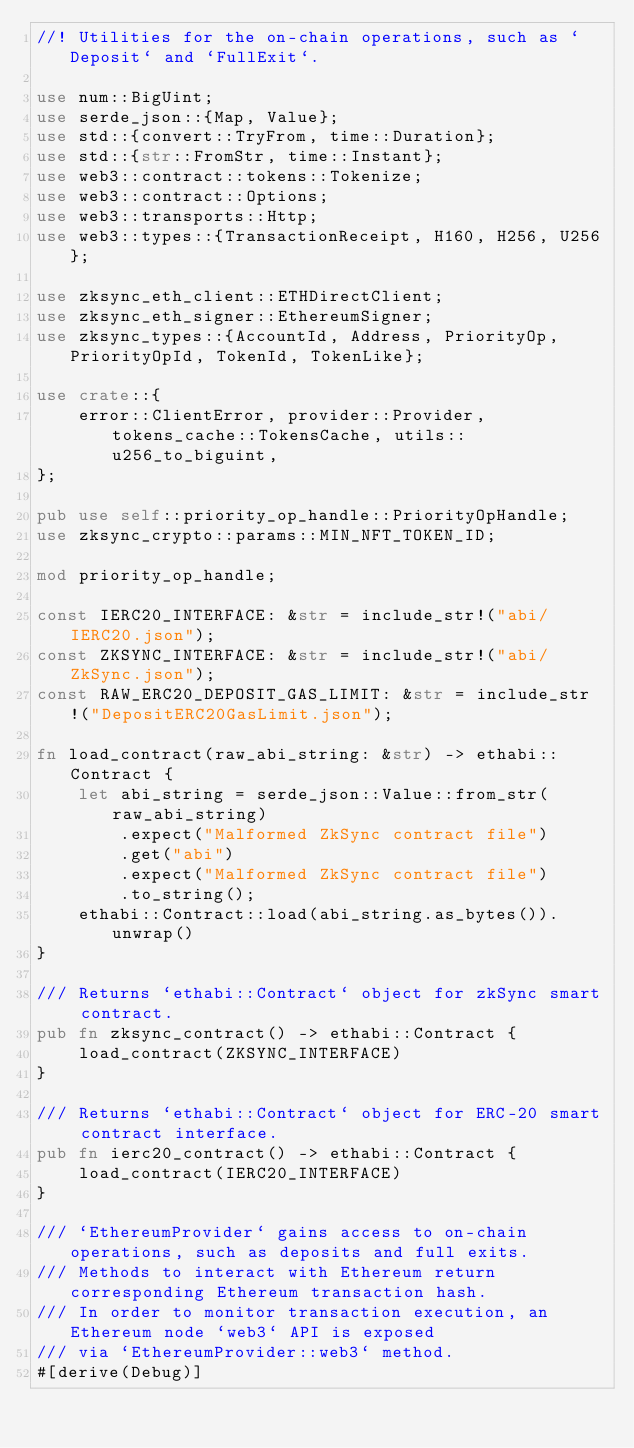Convert code to text. <code><loc_0><loc_0><loc_500><loc_500><_Rust_>//! Utilities for the on-chain operations, such as `Deposit` and `FullExit`.

use num::BigUint;
use serde_json::{Map, Value};
use std::{convert::TryFrom, time::Duration};
use std::{str::FromStr, time::Instant};
use web3::contract::tokens::Tokenize;
use web3::contract::Options;
use web3::transports::Http;
use web3::types::{TransactionReceipt, H160, H256, U256};

use zksync_eth_client::ETHDirectClient;
use zksync_eth_signer::EthereumSigner;
use zksync_types::{AccountId, Address, PriorityOp, PriorityOpId, TokenId, TokenLike};

use crate::{
    error::ClientError, provider::Provider, tokens_cache::TokensCache, utils::u256_to_biguint,
};

pub use self::priority_op_handle::PriorityOpHandle;
use zksync_crypto::params::MIN_NFT_TOKEN_ID;

mod priority_op_handle;

const IERC20_INTERFACE: &str = include_str!("abi/IERC20.json");
const ZKSYNC_INTERFACE: &str = include_str!("abi/ZkSync.json");
const RAW_ERC20_DEPOSIT_GAS_LIMIT: &str = include_str!("DepositERC20GasLimit.json");

fn load_contract(raw_abi_string: &str) -> ethabi::Contract {
    let abi_string = serde_json::Value::from_str(raw_abi_string)
        .expect("Malformed ZkSync contract file")
        .get("abi")
        .expect("Malformed ZkSync contract file")
        .to_string();
    ethabi::Contract::load(abi_string.as_bytes()).unwrap()
}

/// Returns `ethabi::Contract` object for zkSync smart contract.
pub fn zksync_contract() -> ethabi::Contract {
    load_contract(ZKSYNC_INTERFACE)
}

/// Returns `ethabi::Contract` object for ERC-20 smart contract interface.
pub fn ierc20_contract() -> ethabi::Contract {
    load_contract(IERC20_INTERFACE)
}

/// `EthereumProvider` gains access to on-chain operations, such as deposits and full exits.
/// Methods to interact with Ethereum return corresponding Ethereum transaction hash.
/// In order to monitor transaction execution, an Ethereum node `web3` API is exposed
/// via `EthereumProvider::web3` method.
#[derive(Debug)]</code> 